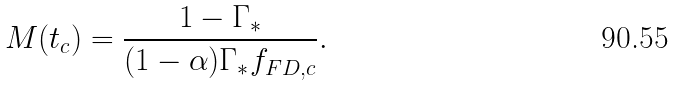Convert formula to latex. <formula><loc_0><loc_0><loc_500><loc_500>M ( t _ { c } ) = \frac { 1 - \Gamma _ { \ast } } { ( 1 - \alpha ) \Gamma _ { \ast } f _ { F D , c } } .</formula> 